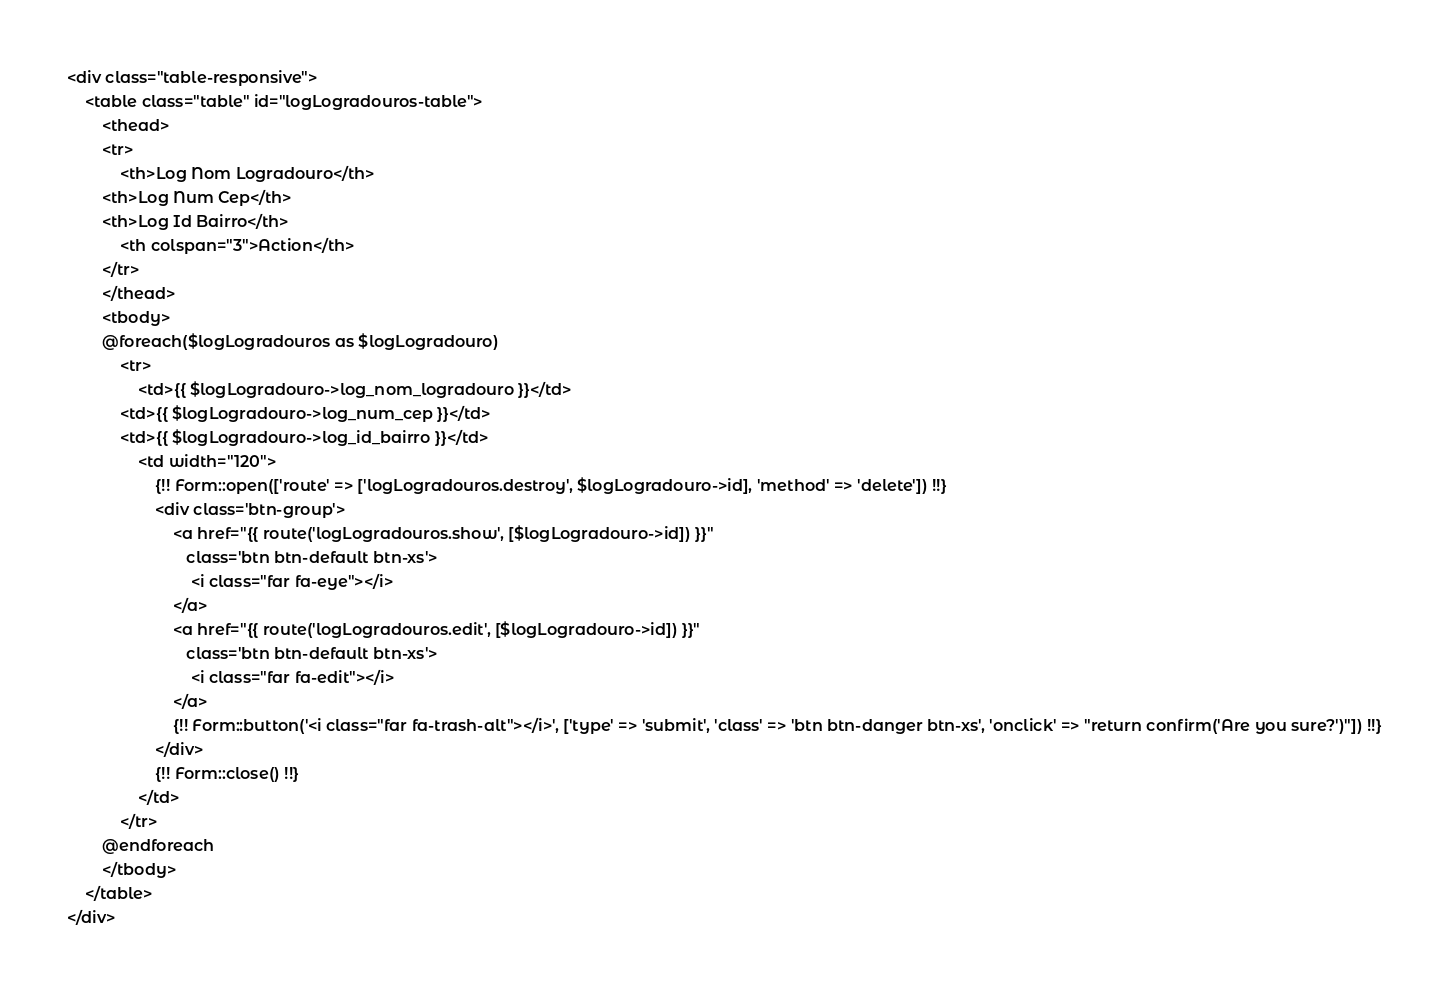<code> <loc_0><loc_0><loc_500><loc_500><_PHP_><div class="table-responsive">
    <table class="table" id="logLogradouros-table">
        <thead>
        <tr>
            <th>Log Nom Logradouro</th>
        <th>Log Num Cep</th>
        <th>Log Id Bairro</th>
            <th colspan="3">Action</th>
        </tr>
        </thead>
        <tbody>
        @foreach($logLogradouros as $logLogradouro)
            <tr>
                <td>{{ $logLogradouro->log_nom_logradouro }}</td>
            <td>{{ $logLogradouro->log_num_cep }}</td>
            <td>{{ $logLogradouro->log_id_bairro }}</td>
                <td width="120">
                    {!! Form::open(['route' => ['logLogradouros.destroy', $logLogradouro->id], 'method' => 'delete']) !!}
                    <div class='btn-group'>
                        <a href="{{ route('logLogradouros.show', [$logLogradouro->id]) }}"
                           class='btn btn-default btn-xs'>
                            <i class="far fa-eye"></i>
                        </a>
                        <a href="{{ route('logLogradouros.edit', [$logLogradouro->id]) }}"
                           class='btn btn-default btn-xs'>
                            <i class="far fa-edit"></i>
                        </a>
                        {!! Form::button('<i class="far fa-trash-alt"></i>', ['type' => 'submit', 'class' => 'btn btn-danger btn-xs', 'onclick' => "return confirm('Are you sure?')"]) !!}
                    </div>
                    {!! Form::close() !!}
                </td>
            </tr>
        @endforeach
        </tbody>
    </table>
</div>
</code> 